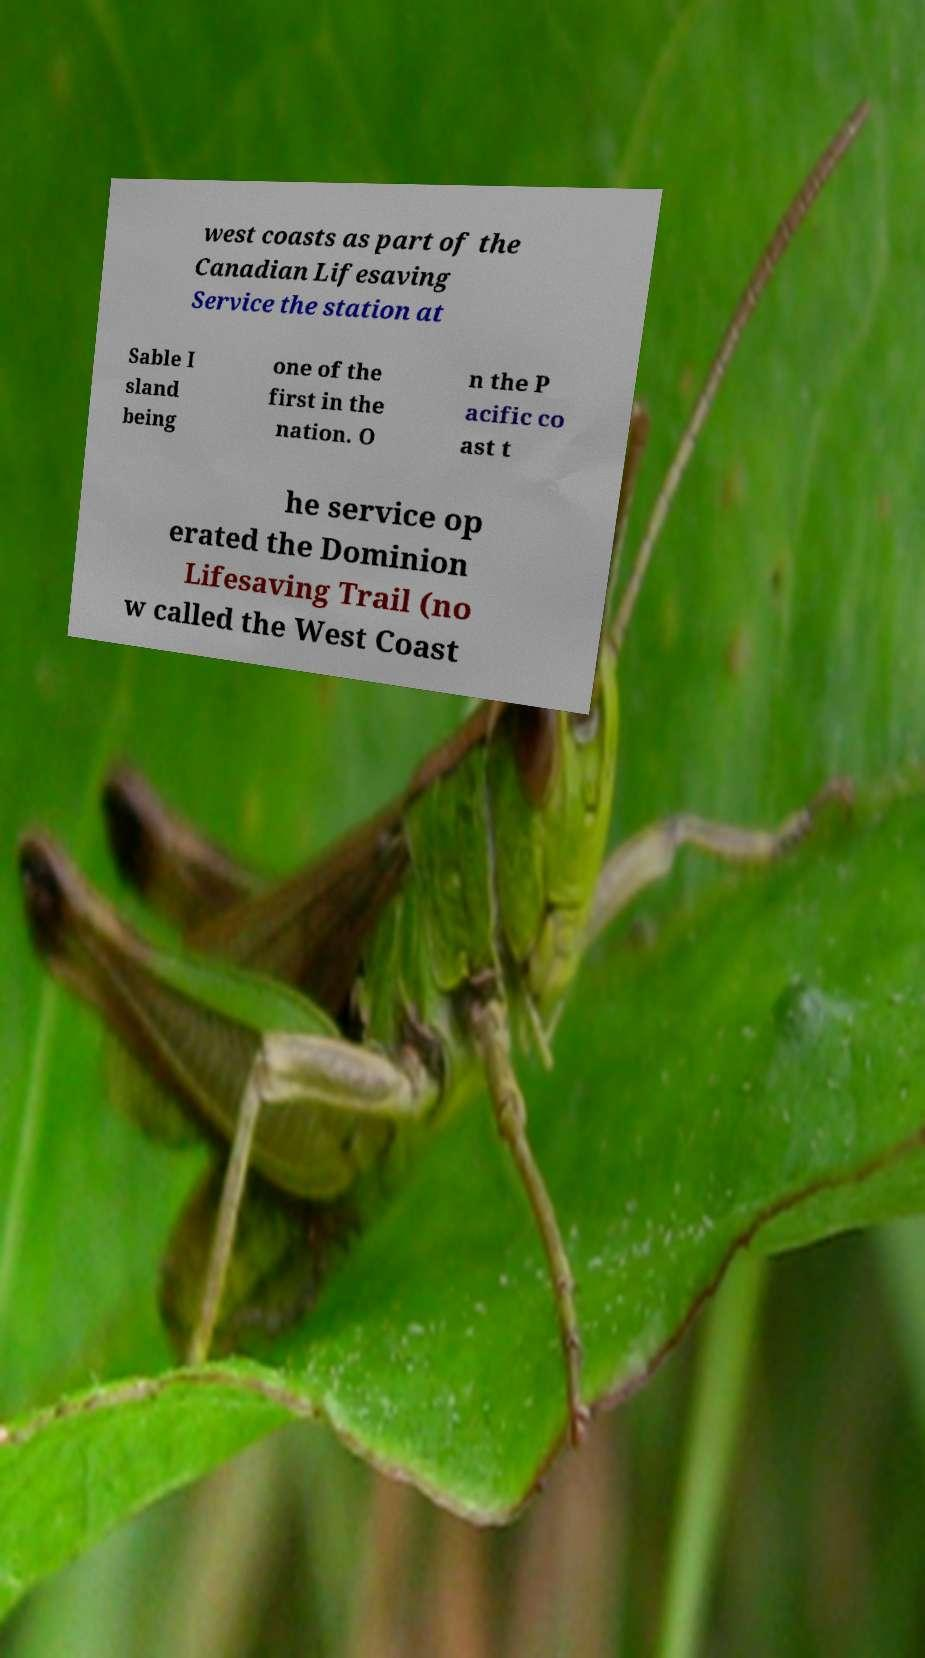Can you read and provide the text displayed in the image?This photo seems to have some interesting text. Can you extract and type it out for me? west coasts as part of the Canadian Lifesaving Service the station at Sable I sland being one of the first in the nation. O n the P acific co ast t he service op erated the Dominion Lifesaving Trail (no w called the West Coast 